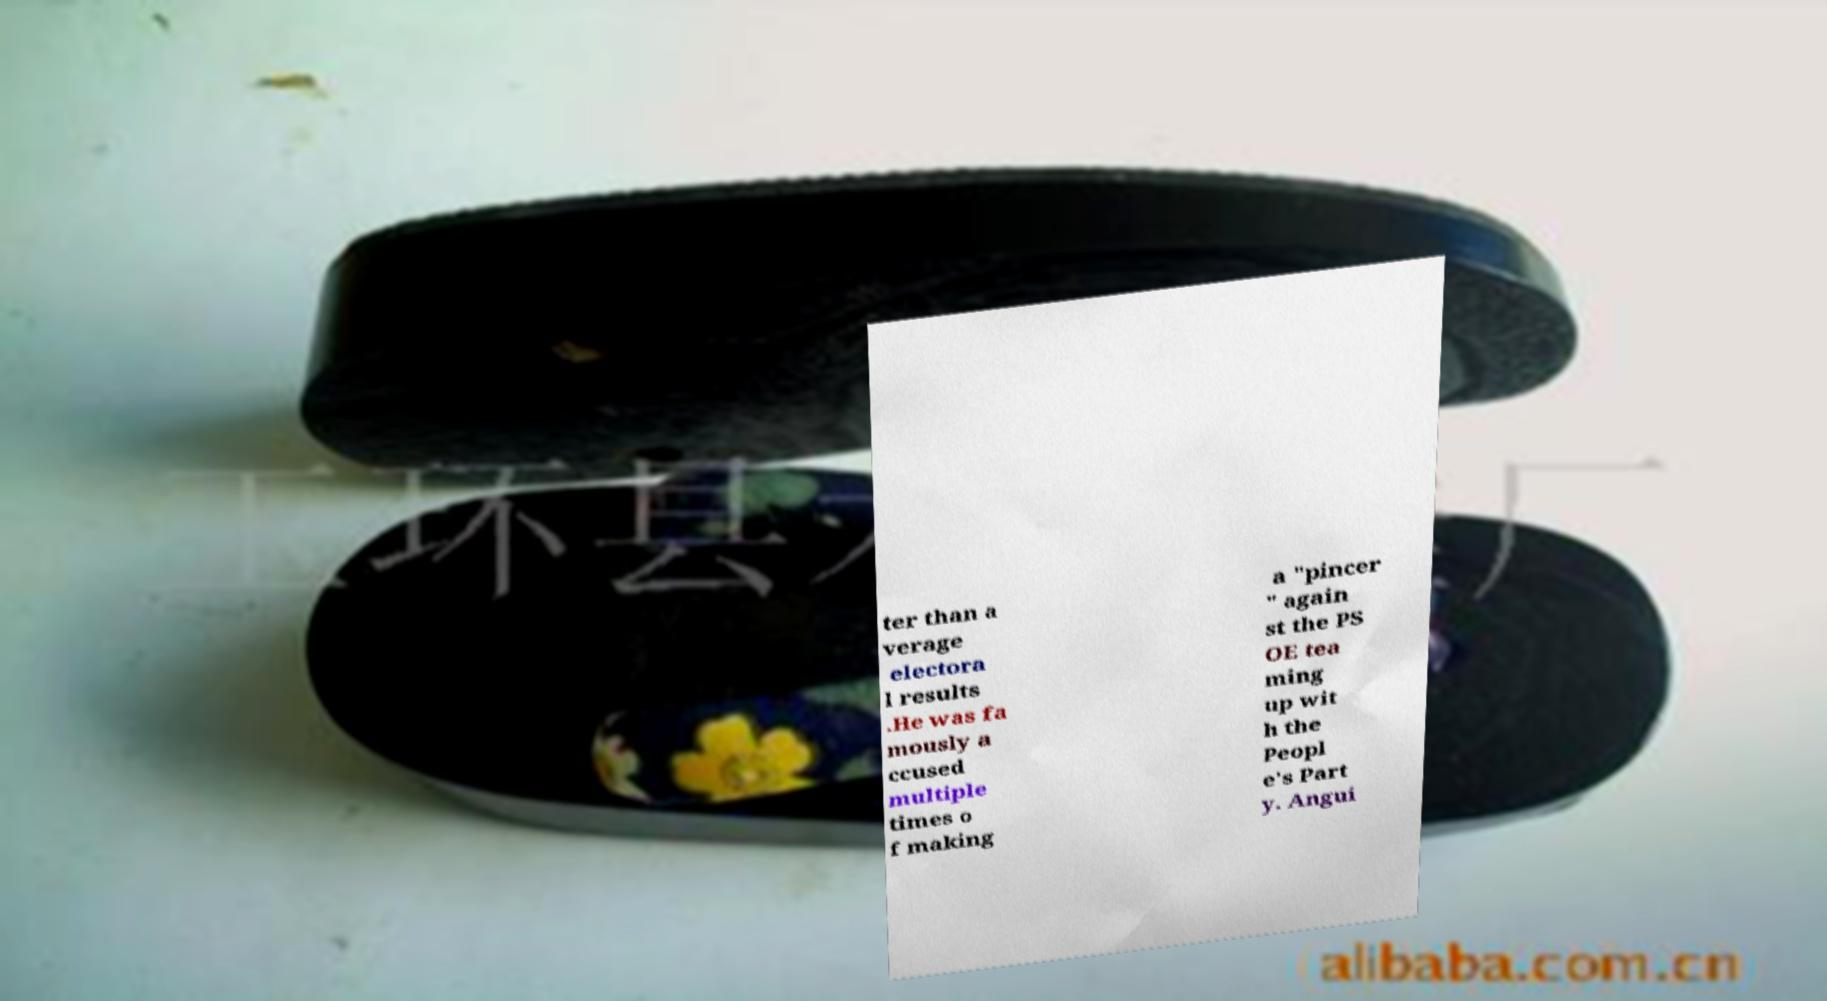There's text embedded in this image that I need extracted. Can you transcribe it verbatim? ter than a verage electora l results .He was fa mously a ccused multiple times o f making a "pincer " again st the PS OE tea ming up wit h the Peopl e's Part y. Angui 